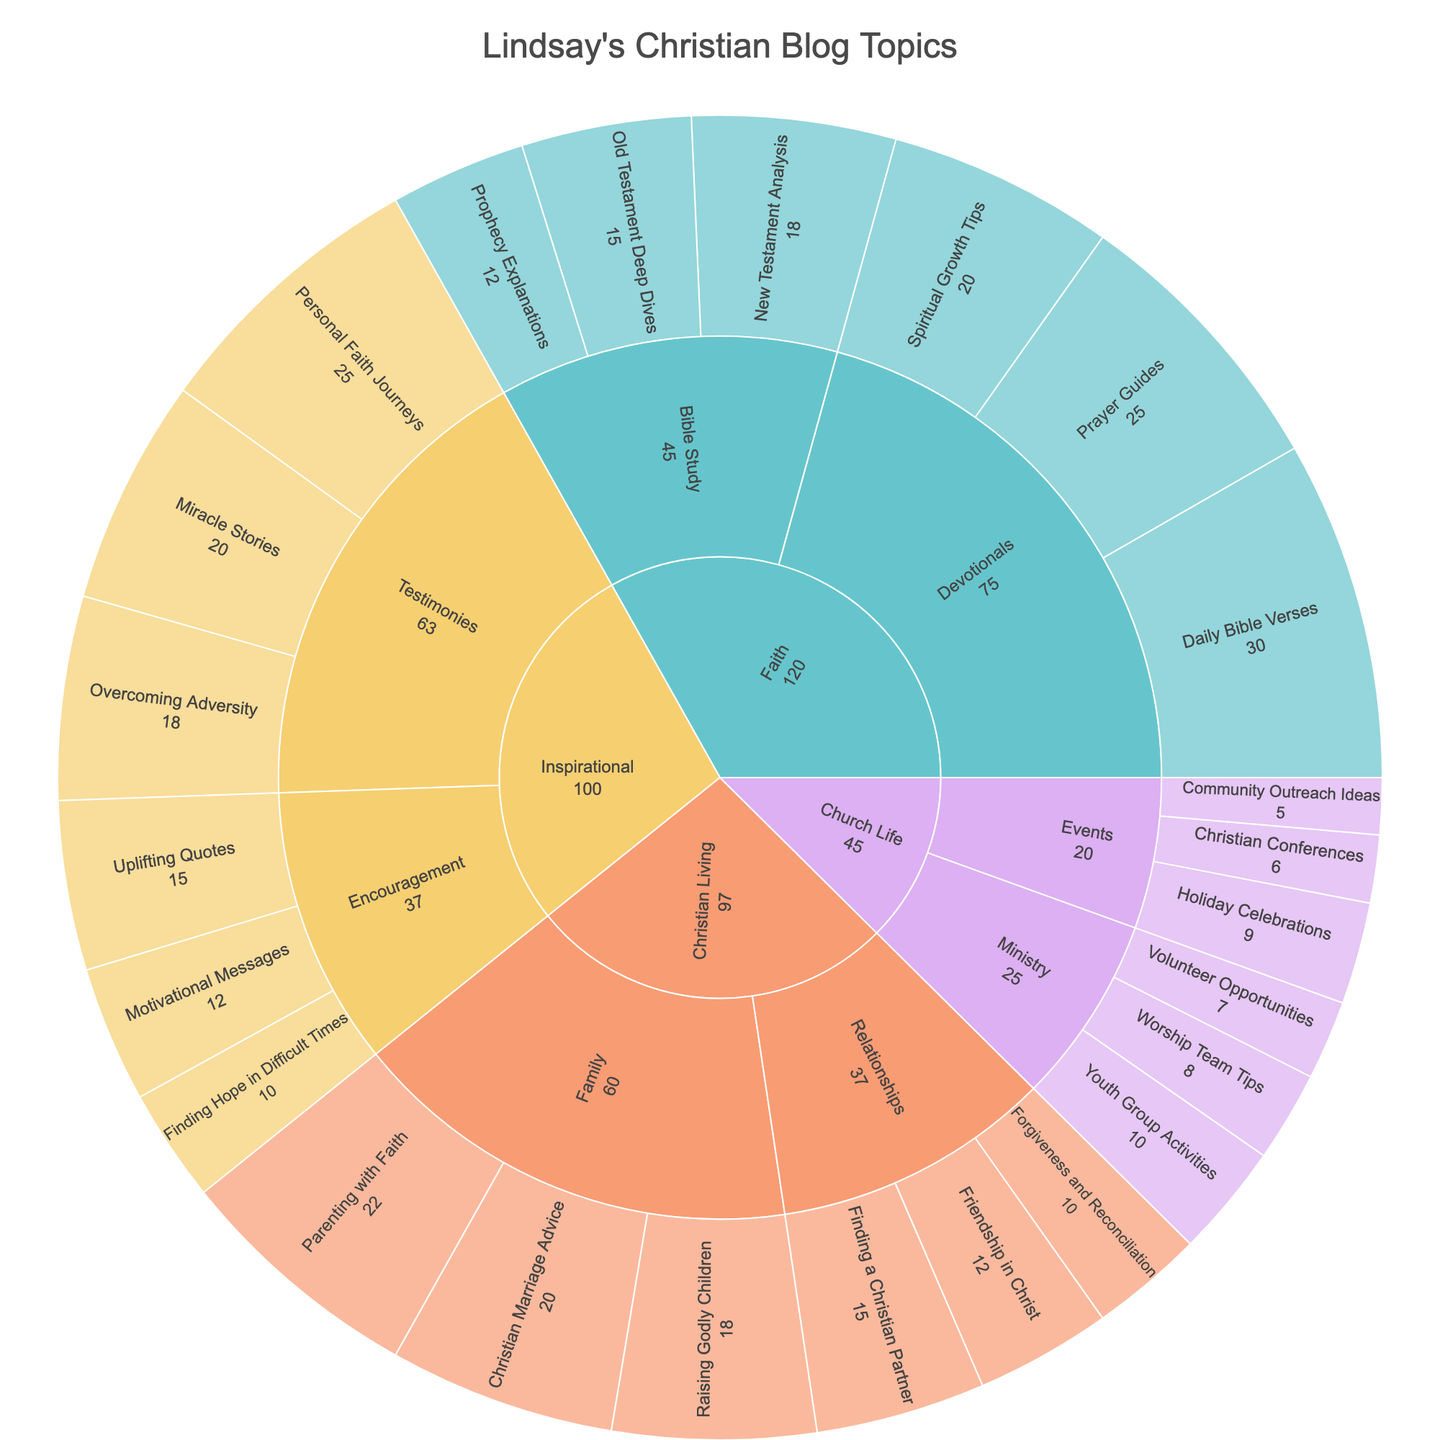What is the title of the Sunburst Plot? The title is typically displayed prominently at the top of the plot. In this case, it reflects the themes covered by the blogger Lindsay.
Answer: Lindsay's Christian Blog Topics Which theme has the highest total value? By visually summing the values of sub-themes within each theme, we can identify which one has the largest combined total.
Answer: Faith What is the sum of values for all 'Devotionals' subjects under the 'Faith' theme? Add the values for 'Daily Bible Verses', 'Prayer Guides', and 'Spiritual Growth Tips' under the 'Faith' theme: 30 + 25 + 20 = 75.
Answer: 75 Which sub-theme under 'Inspirational' has the highest value? Look for the sub-theme with the largest combined value within the 'Inspirational' theme. 'Testimonies' has 25 + 20 + 18 compared to 'Encouragement' with 15 + 12 + 10.
Answer: Testimonies What subject under 'Christian Living' has the lowest value? Compare the values of all subjects under the 'Christian Living' theme and find the smallest one. 'Forgiveness and Reconciliation' has a value of 10.
Answer: Forgiveness and Reconciliation How does the total value of 'Ministry' subjects in 'Church Life' compare to 'Events' subjects? Sum the values of subjects in 'Ministry' (8 + 10 + 7) and compare with those in 'Events' (6 + 9 + 5): Ministry = 25, Events = 20.
Answer: Ministry is greater than Events What is the average value of subjects under the 'Testimonies' sub-theme? Calculate the average by adding the values and dividing by the number of subjects: (25 + 20 + 18) / 3 = 21.
Answer: 21 How many subjects under 'Faith' have a value greater than 15? Identify and count subjects within 'Faith' that exceed the value of 15: Daily Bible Verses, Prayer Guides, New Testament Analysis.
Answer: 3 Which theme has the smallest overall value, and what is it? By observing the sum of values under each theme, compare the totals to find the smallest. 'Church Life' has the smallest sum.
Answer: Church Life, 45 